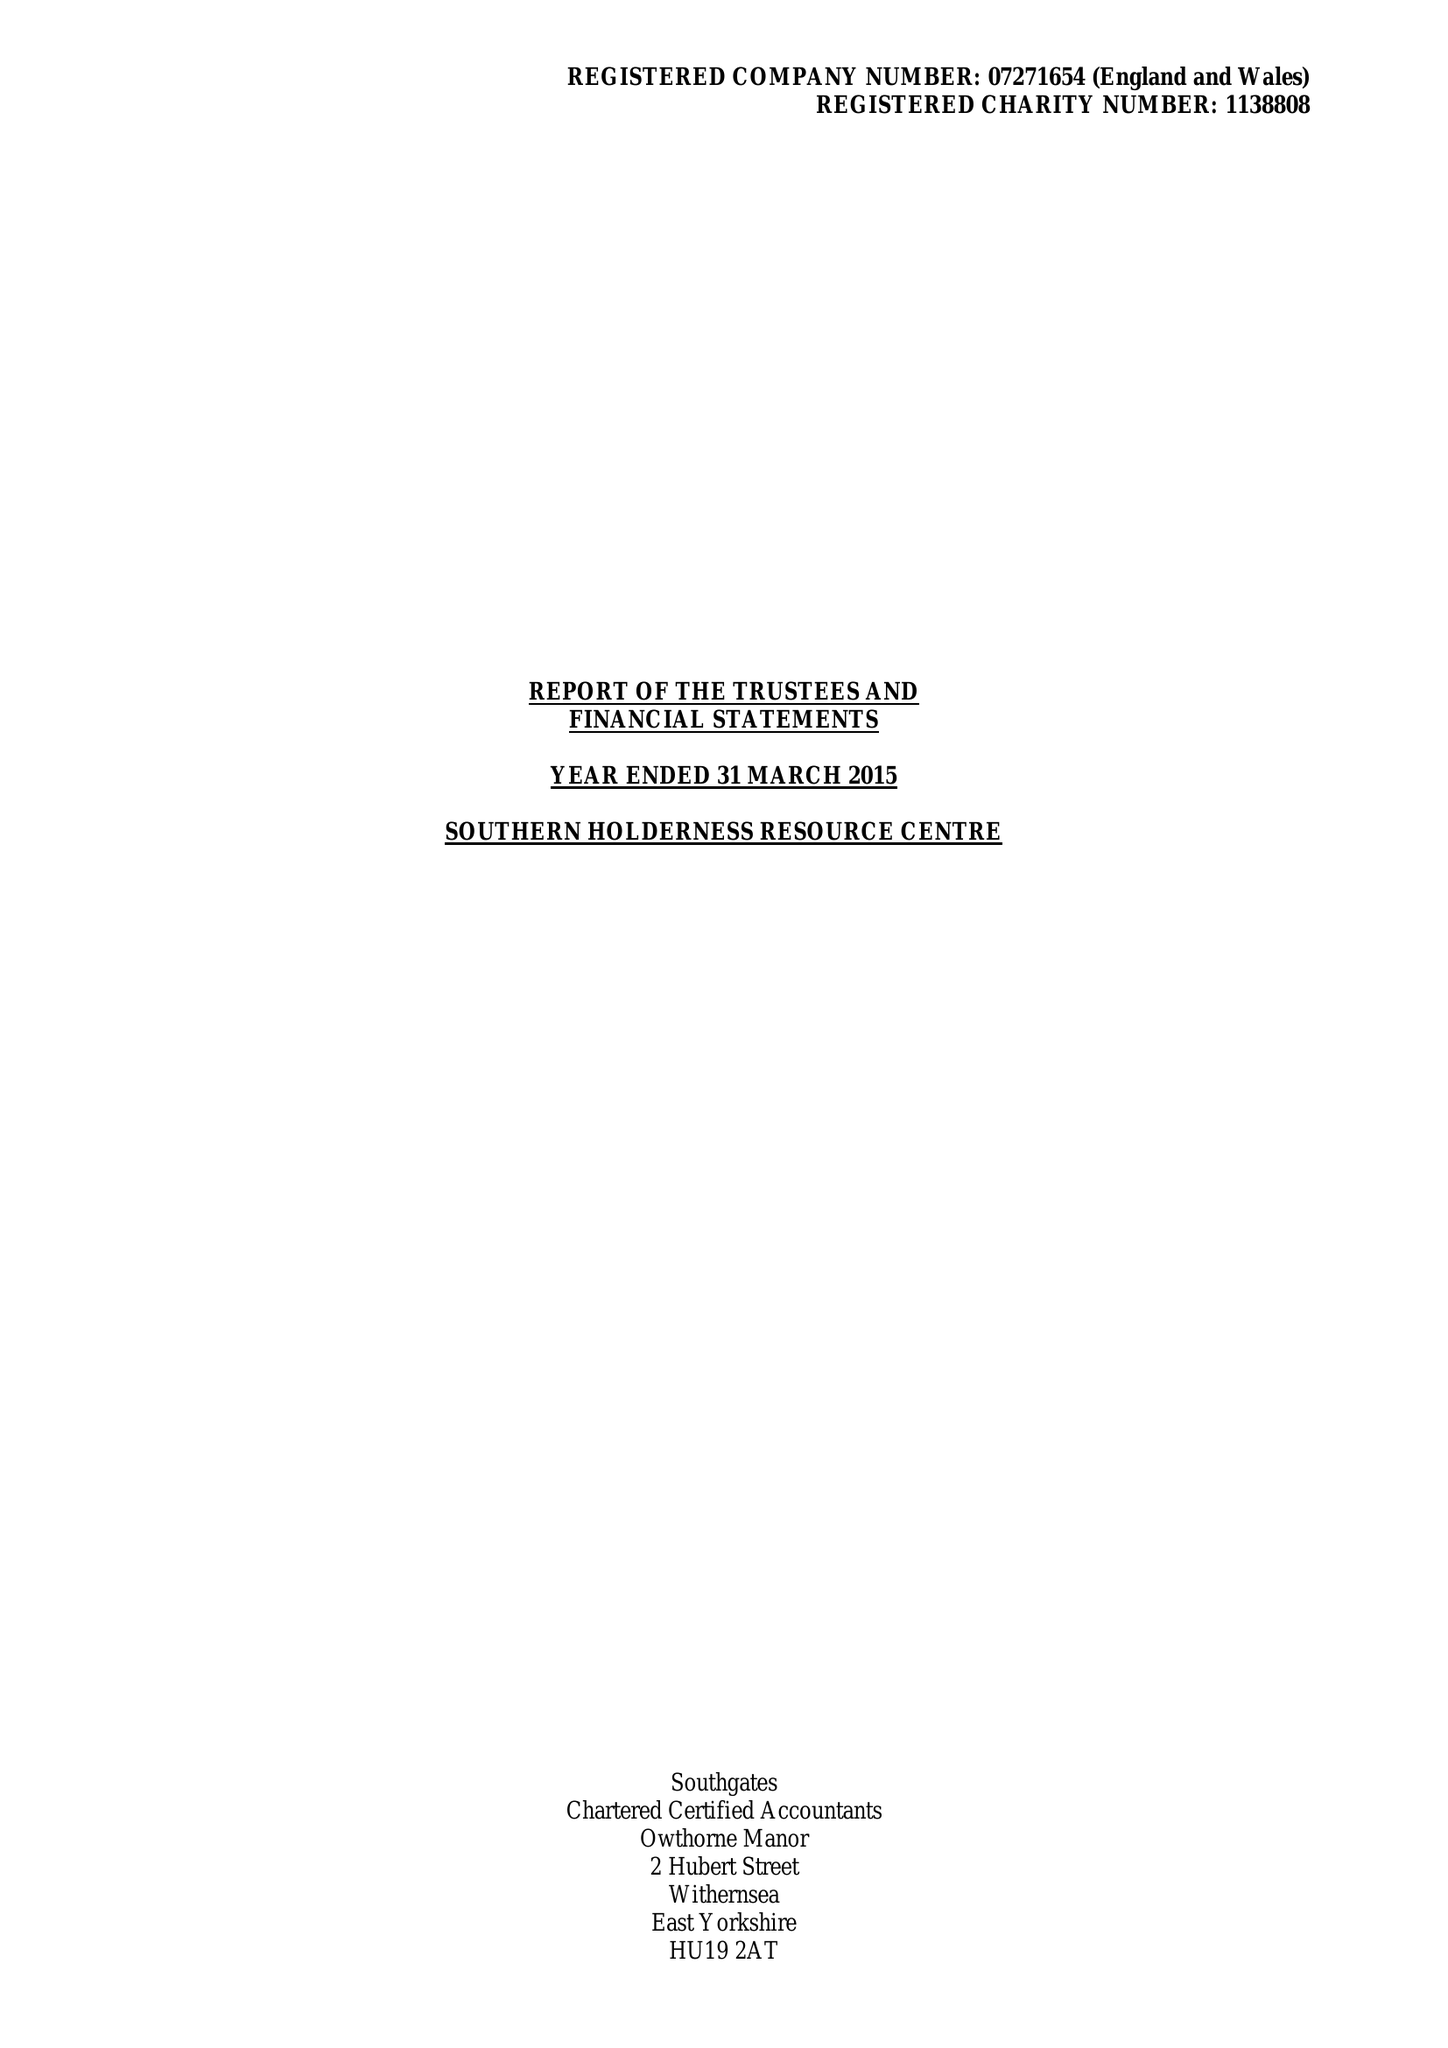What is the value for the charity_number?
Answer the question using a single word or phrase. 1138808 